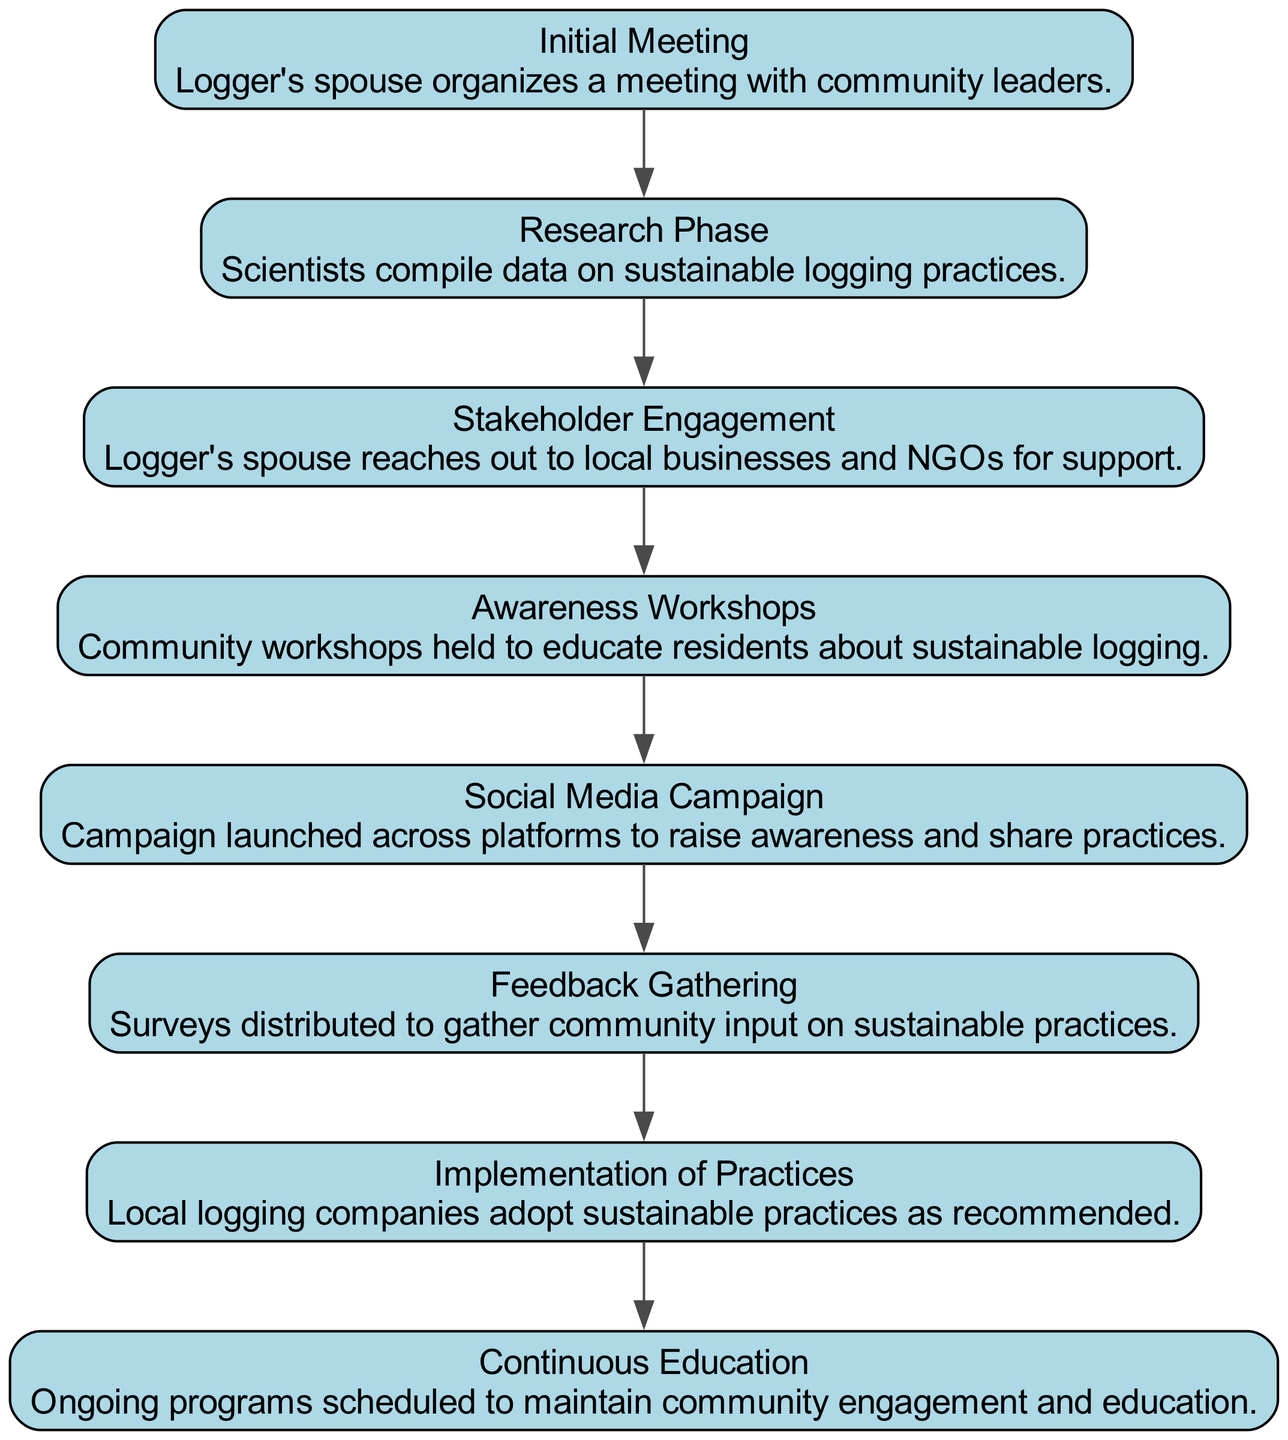What is the first event in the campaign timeline? The first event in the campaign is the "Initial Meeting," which is where the Logger's spouse organizes a meeting with community leaders to kick off the campaign.
Answer: Initial Meeting How many events are listed in the diagram? By counting the number of distinct events represented as nodes in the diagram, we note that there are a total of eight events from "Initial Meeting" to "Continuous Education."
Answer: 8 What follows the "Stakeholder Engagement" event? According to the sequence diagram, after "Stakeholder Engagement," the next event in the timeline is "Awareness Workshops," indicating a progression in the campaign's initiatives.
Answer: Awareness Workshops What event involves scientists? The "Research Phase" specifically includes the involvement of scientists who compile data on sustainable logging practices, highlighting their role in gathering necessary information for the campaign.
Answer: Research Phase Which event features feedback from the community? The event "Feedback Gathering" focuses on distributing surveys to collect input from the community on sustainable practices, making it clear that community feedback is an important element.
Answer: Feedback Gathering Explain the connection between "Implementation of Practices" and "Feedback Gathering." "Feedback Gathering" occurs before "Implementation of Practices," suggesting that the input received from the community is used to inform how the local logging companies adopt the sustainable practices that were recommended. Thus, the successful implementation relies on prior feedback.
Answer: Feedback Gathering leads to Implementation of Practices What is the purpose of the "Social Media Campaign"? The "Social Media Campaign" aims to raise awareness and share practices related to sustainable logging across various platforms, illustrating its role in engaging a wider audience in the initiative.
Answer: Raise awareness Which event runs consecutively after "Research Phase"? Following the "Research Phase," the next event is "Stakeholder Engagement," marking a transition from data gathering to outreach and collaboration with local stakeholders.
Answer: Stakeholder Engagement 